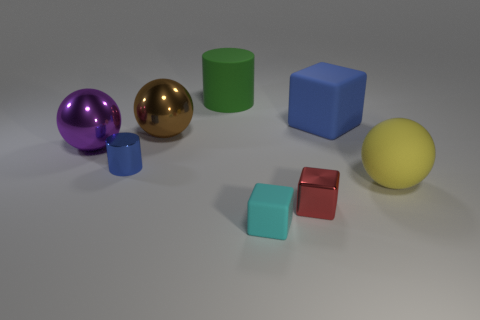Add 2 tiny things. How many objects exist? 10 Subtract all balls. How many objects are left? 5 Subtract all big brown rubber things. Subtract all yellow rubber balls. How many objects are left? 7 Add 3 small red objects. How many small red objects are left? 4 Add 5 tiny red things. How many tiny red things exist? 6 Subtract 0 brown cubes. How many objects are left? 8 